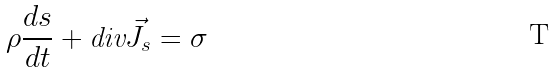Convert formula to latex. <formula><loc_0><loc_0><loc_500><loc_500>\rho \frac { d s } { d t } + \text {div} \vec { J } _ { s } = \sigma</formula> 